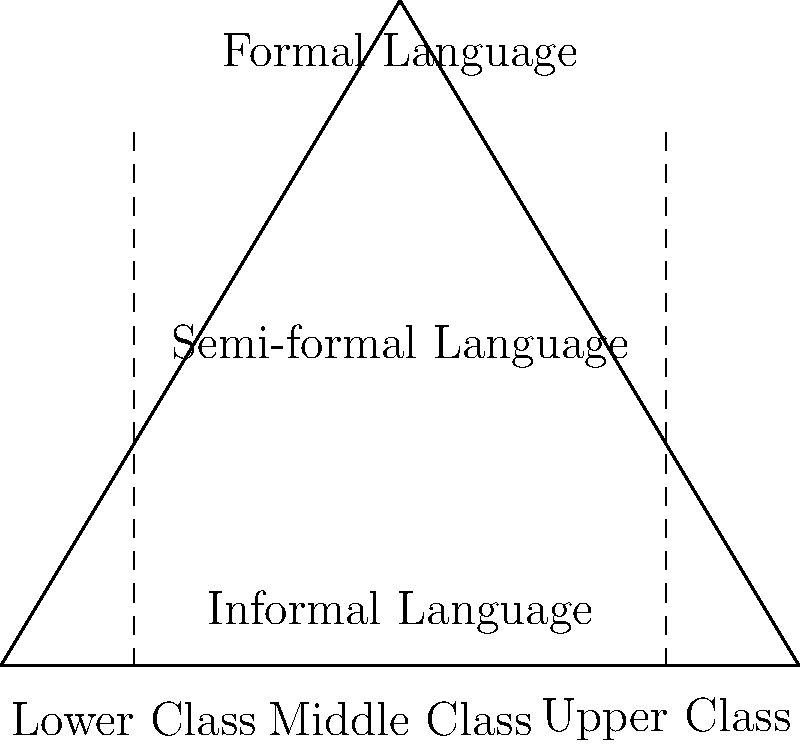Based on the pyramid diagram illustrating the relationship between social hierarchy and linguistic formality, which social class is most likely to use formal language in their everyday interactions, and why might this be the case from a linguistic anthropological perspective? 1. Observe the pyramid structure: The diagram shows a hierarchical relationship between social classes and language formality.

2. Identify the social classes: The bottom of the pyramid is divided into Lower, Middle, and Upper classes.

3. Analyze the language levels: The pyramid is vertically divided into Informal, Semi-formal, and Formal language, with Formal at the top.

4. Interpret the relationship: The diagram suggests that higher social classes correspond to more formal language use.

5. Consider the linguistic anthropological perspective:
   a) Language is shaped by social and cultural factors.
   b) Social hierarchies influence language use and expectations.
   c) Formal language often serves as a marker of status and education.

6. Conclude: The Upper Class is most likely to use formal language in everyday interactions because:
   a) They occupy the highest social position, corresponding to the formal language level.
   b) Formal language use reinforces their social status and distinguishes them from other classes.
   c) Cultural expectations and socialization within upper-class environments likely emphasize formal language use.

7. Reflect on the anthropological implications: This relationship demonstrates how language serves as a tool for maintaining and reproducing social hierarchies and cultural distinctions.
Answer: Upper Class; language reinforces social status and cultural distinctions. 